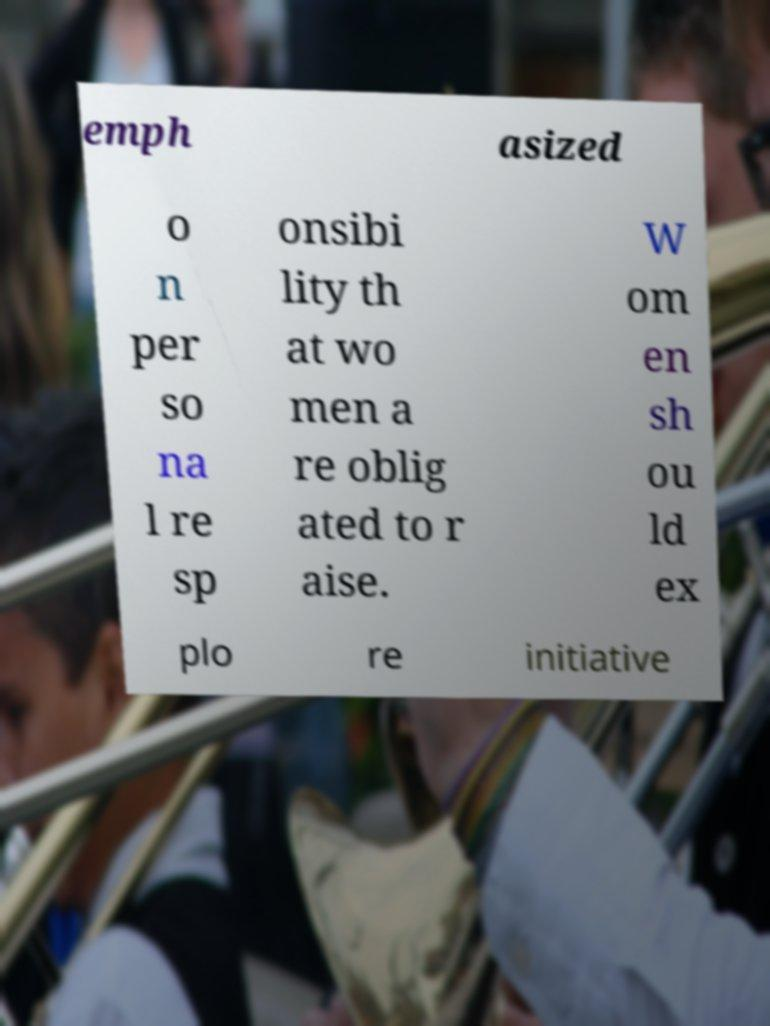Can you accurately transcribe the text from the provided image for me? emph asized o n per so na l re sp onsibi lity th at wo men a re oblig ated to r aise. W om en sh ou ld ex plo re initiative 